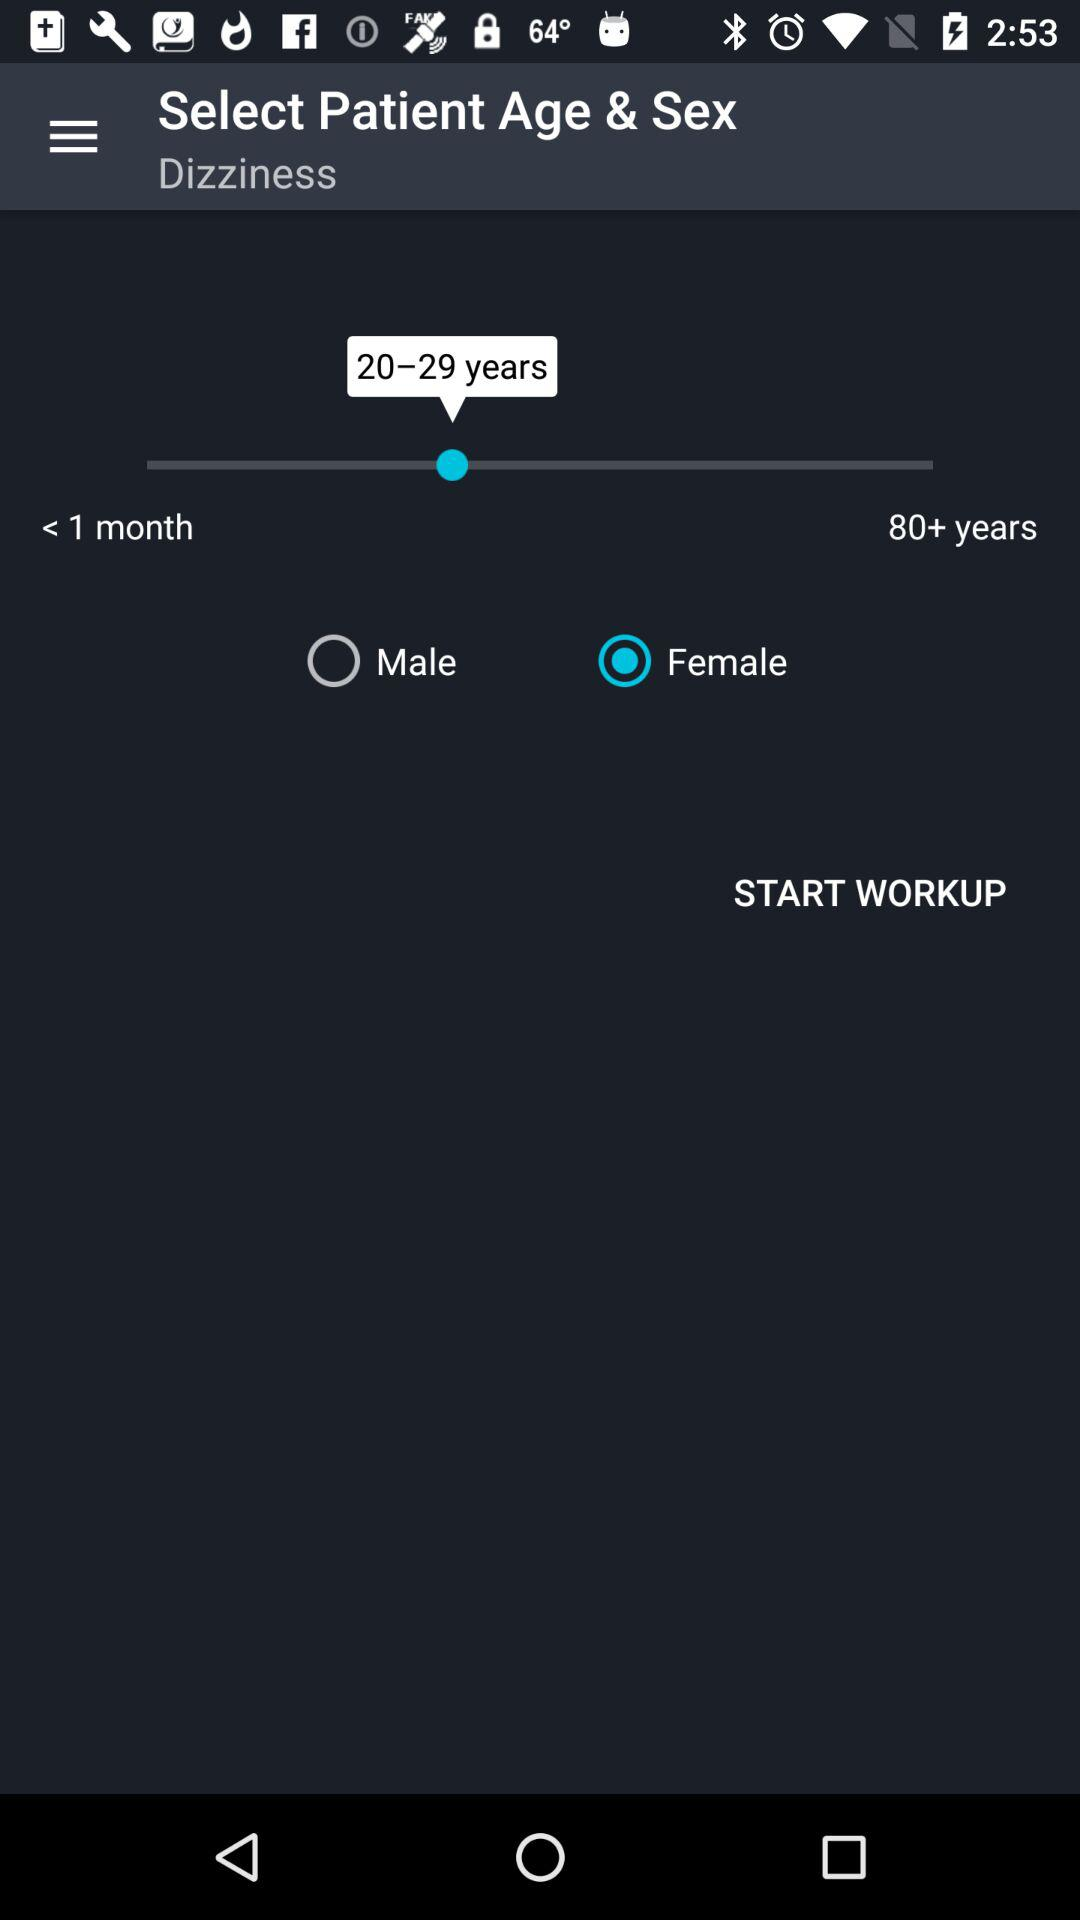What is the selected age range? The selected age range is 20 to 29 years. 